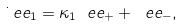<formula> <loc_0><loc_0><loc_500><loc_500>\dot { \ } e e _ { 1 } = \kappa _ { 1 } \ e e _ { + } + \ e e _ { - } ,</formula> 